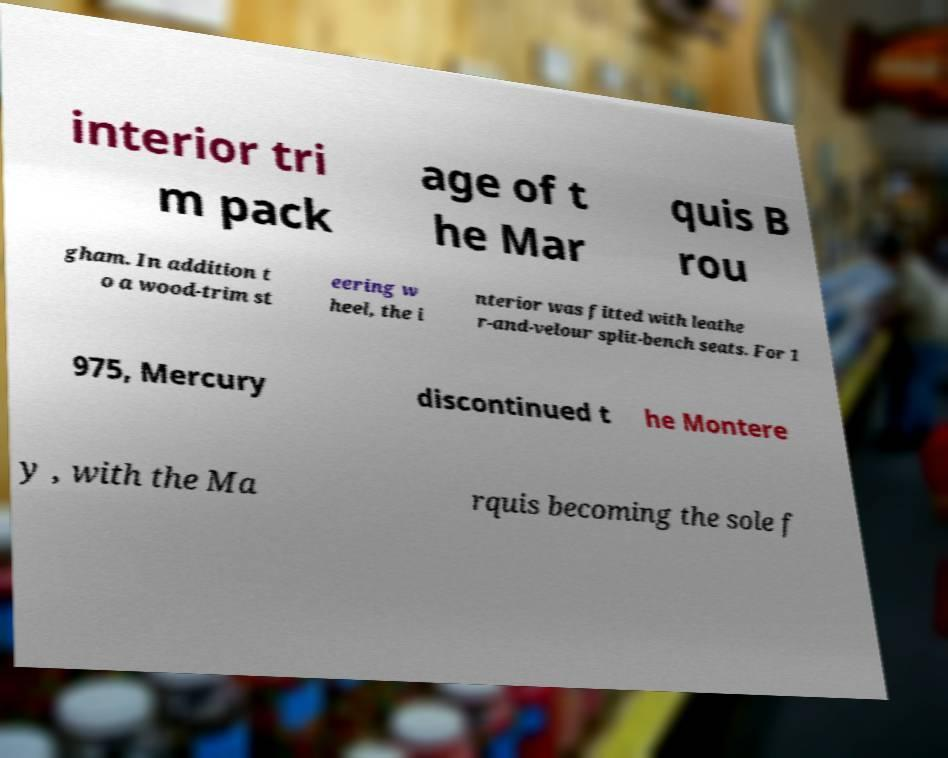For documentation purposes, I need the text within this image transcribed. Could you provide that? interior tri m pack age of t he Mar quis B rou gham. In addition t o a wood-trim st eering w heel, the i nterior was fitted with leathe r-and-velour split-bench seats. For 1 975, Mercury discontinued t he Montere y , with the Ma rquis becoming the sole f 